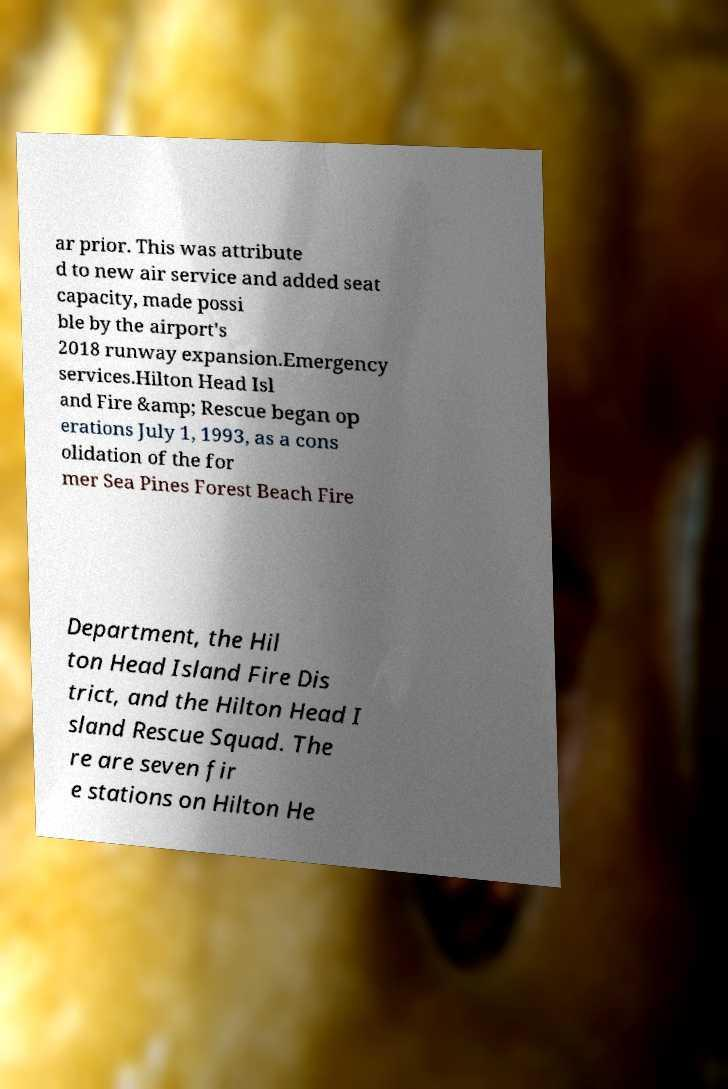For documentation purposes, I need the text within this image transcribed. Could you provide that? ar prior. This was attribute d to new air service and added seat capacity, made possi ble by the airport's 2018 runway expansion.Emergency services.Hilton Head Isl and Fire &amp; Rescue began op erations July 1, 1993, as a cons olidation of the for mer Sea Pines Forest Beach Fire Department, the Hil ton Head Island Fire Dis trict, and the Hilton Head I sland Rescue Squad. The re are seven fir e stations on Hilton He 